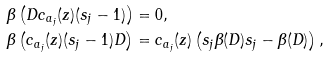<formula> <loc_0><loc_0><loc_500><loc_500>\beta \left ( D c _ { a _ { j } } ( z ) ( s _ { j } - 1 ) \right ) & = 0 , \\ \beta \left ( c _ { a _ { j } } ( z ) ( s _ { j } - 1 ) D \right ) & = c _ { a _ { j } } ( z ) \left ( s _ { j } \beta ( D ) s _ { j } - \beta ( D ) \right ) ,</formula> 